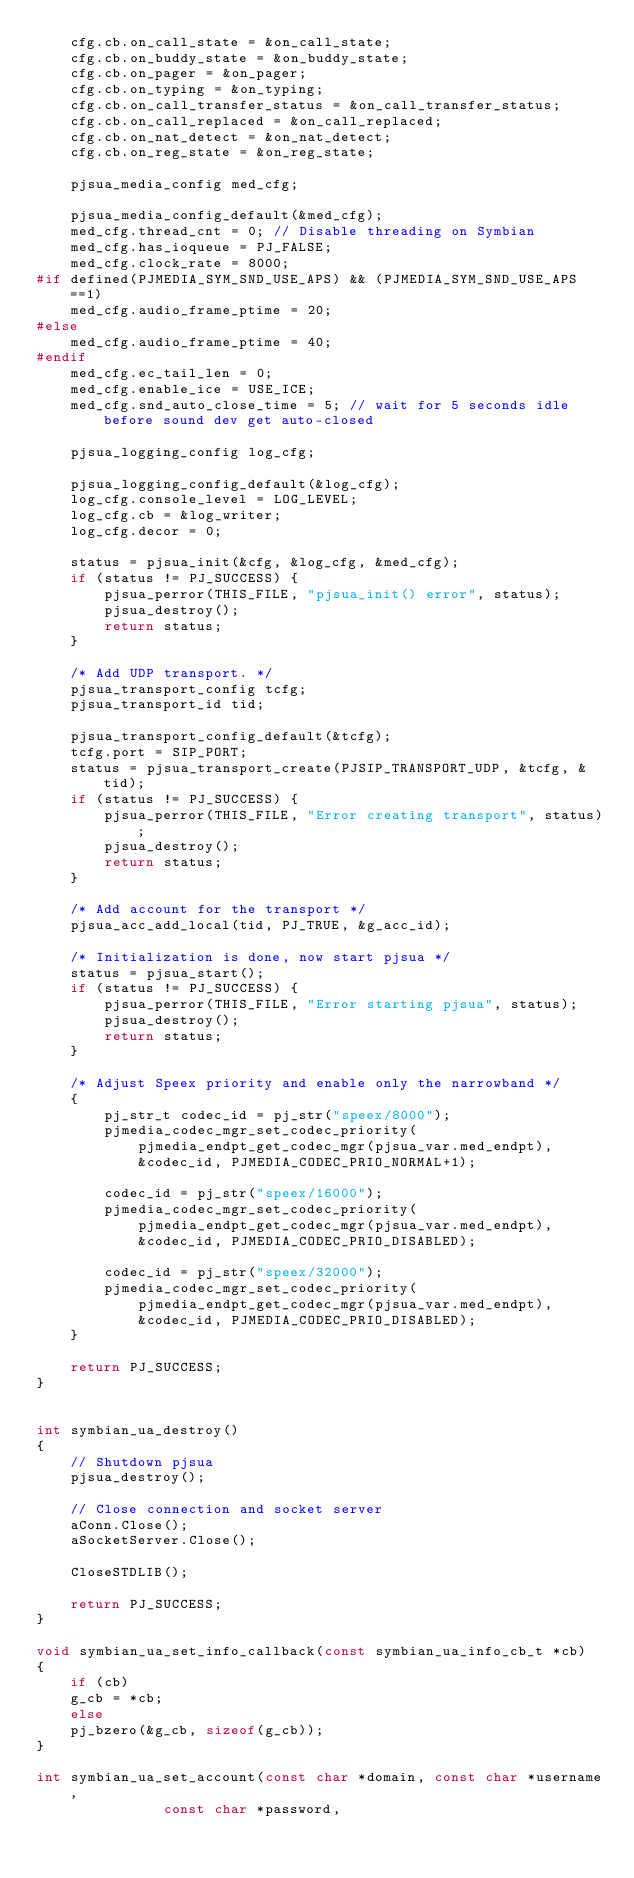Convert code to text. <code><loc_0><loc_0><loc_500><loc_500><_C++_>    cfg.cb.on_call_state = &on_call_state;
    cfg.cb.on_buddy_state = &on_buddy_state;
    cfg.cb.on_pager = &on_pager;
    cfg.cb.on_typing = &on_typing;
    cfg.cb.on_call_transfer_status = &on_call_transfer_status;
    cfg.cb.on_call_replaced = &on_call_replaced;
    cfg.cb.on_nat_detect = &on_nat_detect;
    cfg.cb.on_reg_state = &on_reg_state;

    pjsua_media_config med_cfg;

    pjsua_media_config_default(&med_cfg);
    med_cfg.thread_cnt = 0; // Disable threading on Symbian
    med_cfg.has_ioqueue = PJ_FALSE;
    med_cfg.clock_rate = 8000;
#if defined(PJMEDIA_SYM_SND_USE_APS) && (PJMEDIA_SYM_SND_USE_APS==1)
    med_cfg.audio_frame_ptime = 20;
#else
    med_cfg.audio_frame_ptime = 40;
#endif
    med_cfg.ec_tail_len = 0;
    med_cfg.enable_ice = USE_ICE;
    med_cfg.snd_auto_close_time = 5; // wait for 5 seconds idle before sound dev get auto-closed

    pjsua_logging_config log_cfg;

    pjsua_logging_config_default(&log_cfg);
    log_cfg.console_level = LOG_LEVEL;
    log_cfg.cb = &log_writer;
    log_cfg.decor = 0;

    status = pjsua_init(&cfg, &log_cfg, &med_cfg);
    if (status != PJ_SUCCESS) {
	    pjsua_perror(THIS_FILE, "pjsua_init() error", status);
	    pjsua_destroy();
	    return status;
    }

    /* Add UDP transport. */
    pjsua_transport_config tcfg;
    pjsua_transport_id tid;

    pjsua_transport_config_default(&tcfg);
    tcfg.port = SIP_PORT;
    status = pjsua_transport_create(PJSIP_TRANSPORT_UDP, &tcfg, &tid);
    if (status != PJ_SUCCESS) {
	    pjsua_perror(THIS_FILE, "Error creating transport", status);
	    pjsua_destroy();
	    return status;
    }

    /* Add account for the transport */
    pjsua_acc_add_local(tid, PJ_TRUE, &g_acc_id);

    /* Initialization is done, now start pjsua */
    status = pjsua_start();
    if (status != PJ_SUCCESS) {
    	pjsua_perror(THIS_FILE, "Error starting pjsua", status);
    	pjsua_destroy();
    	return status;
    }

    /* Adjust Speex priority and enable only the narrowband */
    {
        pj_str_t codec_id = pj_str("speex/8000");
        pjmedia_codec_mgr_set_codec_priority( 
        	pjmedia_endpt_get_codec_mgr(pjsua_var.med_endpt),
        	&codec_id, PJMEDIA_CODEC_PRIO_NORMAL+1);

        codec_id = pj_str("speex/16000");
        pjmedia_codec_mgr_set_codec_priority( 
        	pjmedia_endpt_get_codec_mgr(pjsua_var.med_endpt),
        	&codec_id, PJMEDIA_CODEC_PRIO_DISABLED);

        codec_id = pj_str("speex/32000");
        pjmedia_codec_mgr_set_codec_priority( 
        	pjmedia_endpt_get_codec_mgr(pjsua_var.med_endpt),
        	&codec_id, PJMEDIA_CODEC_PRIO_DISABLED);
    }

    return PJ_SUCCESS;
}


int symbian_ua_destroy()
{
    // Shutdown pjsua
    pjsua_destroy();
    
    // Close connection and socket server
    aConn.Close();
    aSocketServer.Close();
    
    CloseSTDLIB();

    return PJ_SUCCESS;
}

void symbian_ua_set_info_callback(const symbian_ua_info_cb_t *cb)
{
    if (cb)
	g_cb = *cb;
    else
	pj_bzero(&g_cb, sizeof(g_cb));
}

int symbian_ua_set_account(const char *domain, const char *username, 
			   const char *password,</code> 